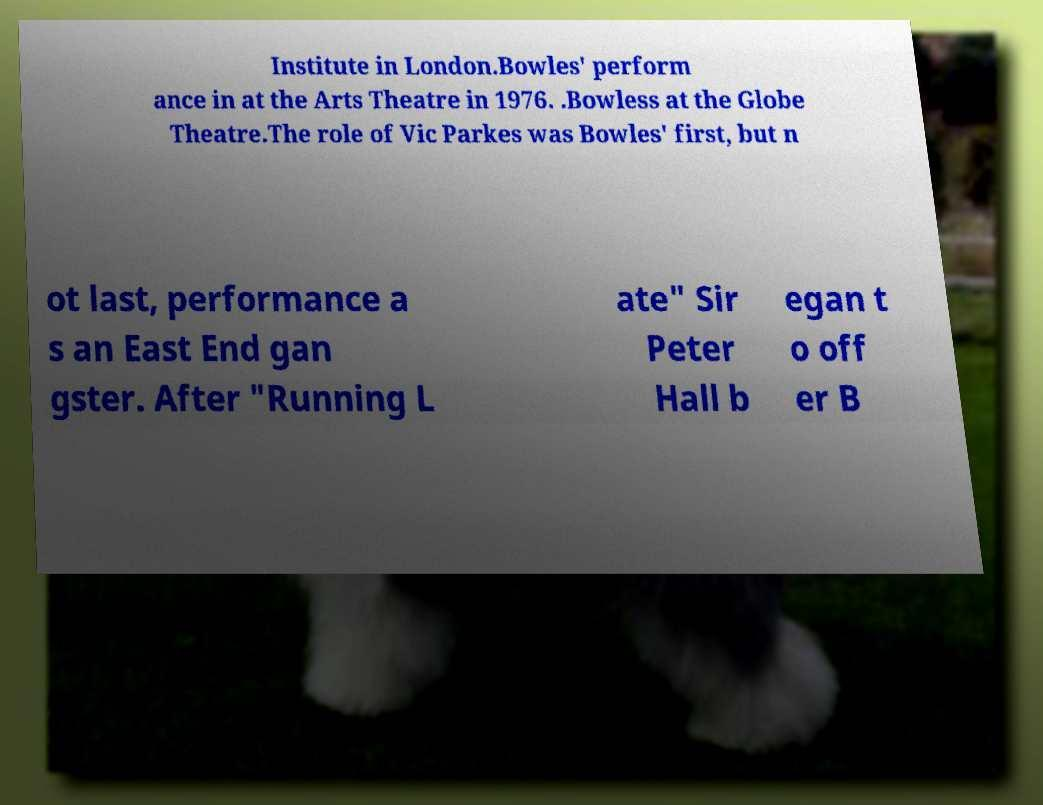I need the written content from this picture converted into text. Can you do that? Institute in London.Bowles' perform ance in at the Arts Theatre in 1976. .Bowless at the Globe Theatre.The role of Vic Parkes was Bowles' first, but n ot last, performance a s an East End gan gster. After "Running L ate" Sir Peter Hall b egan t o off er B 